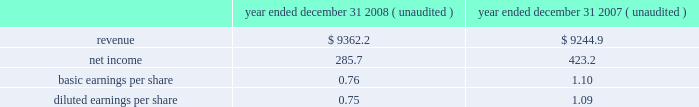The intangible assets identified that were determined to have value as a result of our analysis of allied 2019s projected revenue streams and their related profits include customer relationships , franchise agreements , other municipal agreements , non-compete agreements and trade names .
The fair values for these intangible assets are reflected in the previous table .
Other intangible assets were identified that are considered to be components of either property and equipment or goodwill under u.s .
Gaap , including the value of the permitted and probable airspace at allied 2019s landfills ( property and equipment ) , the going concern element of allied 2019s business ( goodwill ) and its assembled workforce ( goodwill ) .
The going concern element represents the ability of an established business to earn a higher rate of return on an assembled collection of net assets than would be expected if those assets had to be acquired separately .
A substantial portion of this going concern element acquired is represented by allied 2019s infrastructure of market-based collection routes and its related integrated waste transfer and disposal channels , whose value has been included in goodwill .
All of the goodwill and other intangible assets resulting from the acquisition of allied will not be deductible for income tax purposes .
Pro forma information the consolidated financial statements presented for republic include the operating results of allied from the date of the acquisition .
The following pro forma information is presented assuming the merger had been completed as of january 1 , 2007 .
The unaudited pro forma information presented has been prepared for illustrative purposes and is not intended to be indicative of the results of operations that would have actually occurred had the acquisition been consummated at the beginning of the periods presented or of future results of the combined operations .
Furthermore , the pro forma results do not give effect to all cost savings or incremental costs that occur as a result of the integration and consolidation of the acquisition ( in millions , except share and per share amounts ) .
Year ended december 31 , year ended december 31 , ( unaudited ) ( unaudited ) .
The unaudited pro forma financial information includes adjustments for amortization of identifiable intangible assets , accretion of discounts to fair value associated with debt , environmental , self-insurance and other liabilities , accretion of capping , closure and post-closure obligations and amortization of the related assets , and provision for income taxes .
Assets held for sale as a condition of the merger with allied , the department of justice ( doj ) required us to divest of certain assets and related liabilities .
As such , we classified these assets and liabilities as assets held for sale in our consolidated balance sheet at december 31 , 2008 .
Certain of the legacy republic assets classified as held for sale were adjusted to their estimated fair values less costs to sell and resulted in the recognition of an asset impairment loss of $ 1.8 million and $ 6.1 million in our consolidated statements of income for the years ended december 31 , 2009 and 2008 , respectively .
The assets held for sale related to operations that were allied 2019s were recorded at their estimated fair values in our consolidated balance sheet as of december 31 , 2008 in republic services , inc .
And subsidiaries notes to consolidated financial statements , continued .
What was the percent of the decline in the asset impairment loss for the years ended december 31 , 2009 and 2008? 
Rationale: the percentage change is the change in amount from 2008 to 2009 divide by 2008
Computations: ((1.8 - 6.1) - 6.1)
Answer: -10.4. 